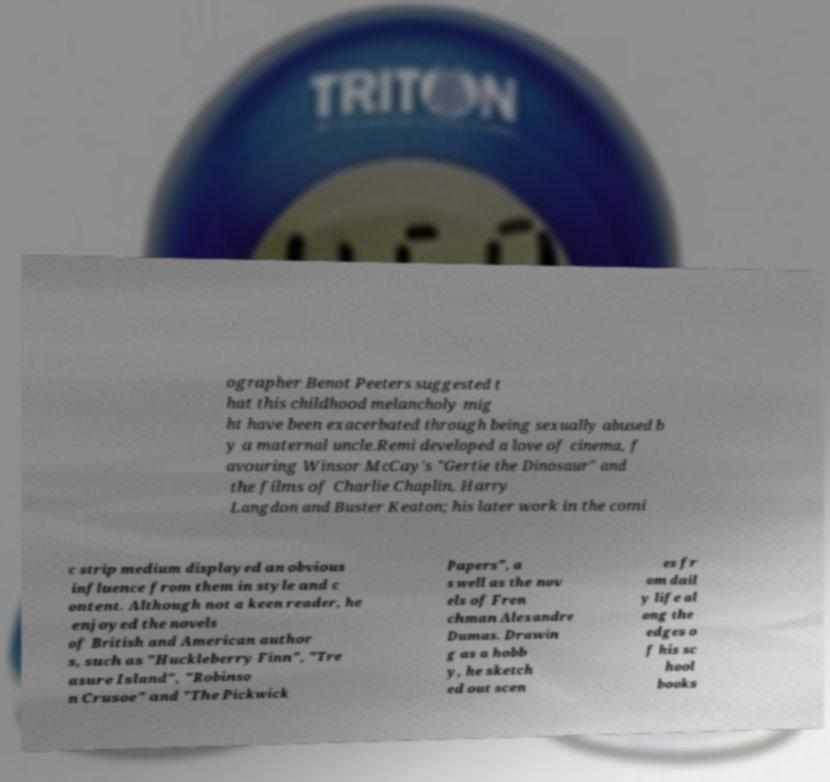What messages or text are displayed in this image? I need them in a readable, typed format. ographer Benot Peeters suggested t hat this childhood melancholy mig ht have been exacerbated through being sexually abused b y a maternal uncle.Remi developed a love of cinema, f avouring Winsor McCay's "Gertie the Dinosaur" and the films of Charlie Chaplin, Harry Langdon and Buster Keaton; his later work in the comi c strip medium displayed an obvious influence from them in style and c ontent. Although not a keen reader, he enjoyed the novels of British and American author s, such as "Huckleberry Finn", "Tre asure Island", "Robinso n Crusoe" and "The Pickwick Papers", a s well as the nov els of Fren chman Alexandre Dumas. Drawin g as a hobb y, he sketch ed out scen es fr om dail y life al ong the edges o f his sc hool books 